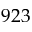<formula> <loc_0><loc_0><loc_500><loc_500>9 2 3</formula> 